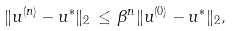<formula> <loc_0><loc_0><loc_500><loc_500>\| u ^ { ( n ) } - u ^ { * } \| _ { 2 } \, \leq \, \beta ^ { n } \| u ^ { ( 0 ) } - u ^ { * } \| _ { 2 } ,</formula> 